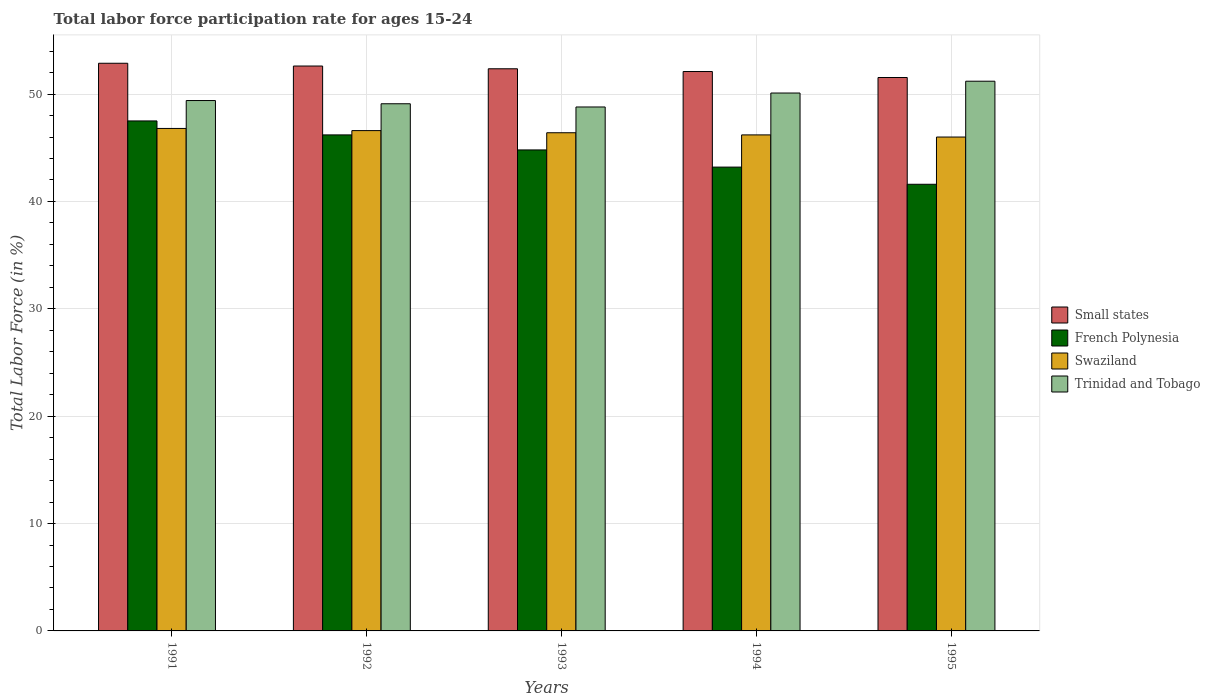Are the number of bars per tick equal to the number of legend labels?
Your answer should be compact. Yes. How many bars are there on the 4th tick from the right?
Make the answer very short. 4. What is the label of the 4th group of bars from the left?
Offer a very short reply. 1994. What is the labor force participation rate in Swaziland in 1995?
Give a very brief answer. 46. Across all years, what is the maximum labor force participation rate in Swaziland?
Provide a succinct answer. 46.8. Across all years, what is the minimum labor force participation rate in Trinidad and Tobago?
Provide a succinct answer. 48.8. What is the total labor force participation rate in Trinidad and Tobago in the graph?
Provide a short and direct response. 248.6. What is the difference between the labor force participation rate in Swaziland in 1992 and that in 1993?
Offer a terse response. 0.2. What is the difference between the labor force participation rate in French Polynesia in 1992 and the labor force participation rate in Small states in 1993?
Ensure brevity in your answer.  -6.16. What is the average labor force participation rate in Small states per year?
Your answer should be compact. 52.3. In the year 1993, what is the difference between the labor force participation rate in Swaziland and labor force participation rate in French Polynesia?
Your answer should be compact. 1.6. What is the ratio of the labor force participation rate in Small states in 1992 to that in 1993?
Offer a terse response. 1. Is the labor force participation rate in Swaziland in 1992 less than that in 1993?
Give a very brief answer. No. What is the difference between the highest and the second highest labor force participation rate in French Polynesia?
Offer a terse response. 1.3. What is the difference between the highest and the lowest labor force participation rate in Swaziland?
Ensure brevity in your answer.  0.8. Is it the case that in every year, the sum of the labor force participation rate in French Polynesia and labor force participation rate in Trinidad and Tobago is greater than the sum of labor force participation rate in Swaziland and labor force participation rate in Small states?
Offer a terse response. Yes. What does the 1st bar from the left in 1995 represents?
Ensure brevity in your answer.  Small states. What does the 1st bar from the right in 1993 represents?
Your response must be concise. Trinidad and Tobago. Does the graph contain any zero values?
Your response must be concise. No. Does the graph contain grids?
Give a very brief answer. Yes. Where does the legend appear in the graph?
Provide a short and direct response. Center right. What is the title of the graph?
Offer a terse response. Total labor force participation rate for ages 15-24. What is the label or title of the Y-axis?
Offer a very short reply. Total Labor Force (in %). What is the Total Labor Force (in %) in Small states in 1991?
Give a very brief answer. 52.87. What is the Total Labor Force (in %) in French Polynesia in 1991?
Your answer should be very brief. 47.5. What is the Total Labor Force (in %) of Swaziland in 1991?
Your response must be concise. 46.8. What is the Total Labor Force (in %) of Trinidad and Tobago in 1991?
Provide a succinct answer. 49.4. What is the Total Labor Force (in %) in Small states in 1992?
Give a very brief answer. 52.61. What is the Total Labor Force (in %) of French Polynesia in 1992?
Offer a terse response. 46.2. What is the Total Labor Force (in %) of Swaziland in 1992?
Offer a very short reply. 46.6. What is the Total Labor Force (in %) of Trinidad and Tobago in 1992?
Ensure brevity in your answer.  49.1. What is the Total Labor Force (in %) in Small states in 1993?
Give a very brief answer. 52.36. What is the Total Labor Force (in %) in French Polynesia in 1993?
Ensure brevity in your answer.  44.8. What is the Total Labor Force (in %) in Swaziland in 1993?
Your response must be concise. 46.4. What is the Total Labor Force (in %) in Trinidad and Tobago in 1993?
Provide a succinct answer. 48.8. What is the Total Labor Force (in %) of Small states in 1994?
Keep it short and to the point. 52.1. What is the Total Labor Force (in %) in French Polynesia in 1994?
Your response must be concise. 43.2. What is the Total Labor Force (in %) of Swaziland in 1994?
Give a very brief answer. 46.2. What is the Total Labor Force (in %) in Trinidad and Tobago in 1994?
Offer a very short reply. 50.1. What is the Total Labor Force (in %) in Small states in 1995?
Offer a terse response. 51.54. What is the Total Labor Force (in %) of French Polynesia in 1995?
Make the answer very short. 41.6. What is the Total Labor Force (in %) of Trinidad and Tobago in 1995?
Give a very brief answer. 51.2. Across all years, what is the maximum Total Labor Force (in %) of Small states?
Give a very brief answer. 52.87. Across all years, what is the maximum Total Labor Force (in %) of French Polynesia?
Your answer should be compact. 47.5. Across all years, what is the maximum Total Labor Force (in %) of Swaziland?
Provide a succinct answer. 46.8. Across all years, what is the maximum Total Labor Force (in %) of Trinidad and Tobago?
Provide a short and direct response. 51.2. Across all years, what is the minimum Total Labor Force (in %) in Small states?
Offer a terse response. 51.54. Across all years, what is the minimum Total Labor Force (in %) of French Polynesia?
Your answer should be very brief. 41.6. Across all years, what is the minimum Total Labor Force (in %) in Trinidad and Tobago?
Provide a short and direct response. 48.8. What is the total Total Labor Force (in %) of Small states in the graph?
Offer a terse response. 261.49. What is the total Total Labor Force (in %) of French Polynesia in the graph?
Your answer should be very brief. 223.3. What is the total Total Labor Force (in %) of Swaziland in the graph?
Keep it short and to the point. 232. What is the total Total Labor Force (in %) of Trinidad and Tobago in the graph?
Give a very brief answer. 248.6. What is the difference between the Total Labor Force (in %) in Small states in 1991 and that in 1992?
Provide a short and direct response. 0.26. What is the difference between the Total Labor Force (in %) in Small states in 1991 and that in 1993?
Make the answer very short. 0.51. What is the difference between the Total Labor Force (in %) of French Polynesia in 1991 and that in 1993?
Make the answer very short. 2.7. What is the difference between the Total Labor Force (in %) of Swaziland in 1991 and that in 1993?
Provide a short and direct response. 0.4. What is the difference between the Total Labor Force (in %) of Small states in 1991 and that in 1994?
Keep it short and to the point. 0.77. What is the difference between the Total Labor Force (in %) of Small states in 1991 and that in 1995?
Offer a terse response. 1.33. What is the difference between the Total Labor Force (in %) in Swaziland in 1991 and that in 1995?
Your answer should be compact. 0.8. What is the difference between the Total Labor Force (in %) in Small states in 1992 and that in 1993?
Provide a short and direct response. 0.26. What is the difference between the Total Labor Force (in %) in Small states in 1992 and that in 1994?
Ensure brevity in your answer.  0.51. What is the difference between the Total Labor Force (in %) in French Polynesia in 1992 and that in 1994?
Provide a succinct answer. 3. What is the difference between the Total Labor Force (in %) of Swaziland in 1992 and that in 1994?
Ensure brevity in your answer.  0.4. What is the difference between the Total Labor Force (in %) in Small states in 1992 and that in 1995?
Keep it short and to the point. 1.07. What is the difference between the Total Labor Force (in %) in French Polynesia in 1992 and that in 1995?
Keep it short and to the point. 4.6. What is the difference between the Total Labor Force (in %) of Swaziland in 1992 and that in 1995?
Your response must be concise. 0.6. What is the difference between the Total Labor Force (in %) in Trinidad and Tobago in 1992 and that in 1995?
Keep it short and to the point. -2.1. What is the difference between the Total Labor Force (in %) in Small states in 1993 and that in 1994?
Make the answer very short. 0.25. What is the difference between the Total Labor Force (in %) of Swaziland in 1993 and that in 1994?
Provide a short and direct response. 0.2. What is the difference between the Total Labor Force (in %) of Small states in 1993 and that in 1995?
Provide a short and direct response. 0.81. What is the difference between the Total Labor Force (in %) of Trinidad and Tobago in 1993 and that in 1995?
Your response must be concise. -2.4. What is the difference between the Total Labor Force (in %) of Small states in 1994 and that in 1995?
Offer a very short reply. 0.56. What is the difference between the Total Labor Force (in %) in Trinidad and Tobago in 1994 and that in 1995?
Ensure brevity in your answer.  -1.1. What is the difference between the Total Labor Force (in %) in Small states in 1991 and the Total Labor Force (in %) in French Polynesia in 1992?
Offer a very short reply. 6.67. What is the difference between the Total Labor Force (in %) of Small states in 1991 and the Total Labor Force (in %) of Swaziland in 1992?
Make the answer very short. 6.27. What is the difference between the Total Labor Force (in %) in Small states in 1991 and the Total Labor Force (in %) in Trinidad and Tobago in 1992?
Offer a very short reply. 3.77. What is the difference between the Total Labor Force (in %) of French Polynesia in 1991 and the Total Labor Force (in %) of Trinidad and Tobago in 1992?
Provide a succinct answer. -1.6. What is the difference between the Total Labor Force (in %) of Small states in 1991 and the Total Labor Force (in %) of French Polynesia in 1993?
Offer a terse response. 8.07. What is the difference between the Total Labor Force (in %) of Small states in 1991 and the Total Labor Force (in %) of Swaziland in 1993?
Offer a terse response. 6.47. What is the difference between the Total Labor Force (in %) in Small states in 1991 and the Total Labor Force (in %) in Trinidad and Tobago in 1993?
Your answer should be compact. 4.07. What is the difference between the Total Labor Force (in %) of Small states in 1991 and the Total Labor Force (in %) of French Polynesia in 1994?
Offer a very short reply. 9.67. What is the difference between the Total Labor Force (in %) in Small states in 1991 and the Total Labor Force (in %) in Swaziland in 1994?
Offer a very short reply. 6.67. What is the difference between the Total Labor Force (in %) of Small states in 1991 and the Total Labor Force (in %) of Trinidad and Tobago in 1994?
Your answer should be compact. 2.77. What is the difference between the Total Labor Force (in %) in French Polynesia in 1991 and the Total Labor Force (in %) in Trinidad and Tobago in 1994?
Your response must be concise. -2.6. What is the difference between the Total Labor Force (in %) in Small states in 1991 and the Total Labor Force (in %) in French Polynesia in 1995?
Provide a short and direct response. 11.27. What is the difference between the Total Labor Force (in %) in Small states in 1991 and the Total Labor Force (in %) in Swaziland in 1995?
Offer a terse response. 6.87. What is the difference between the Total Labor Force (in %) of Small states in 1991 and the Total Labor Force (in %) of Trinidad and Tobago in 1995?
Your answer should be very brief. 1.67. What is the difference between the Total Labor Force (in %) of French Polynesia in 1991 and the Total Labor Force (in %) of Swaziland in 1995?
Offer a very short reply. 1.5. What is the difference between the Total Labor Force (in %) of French Polynesia in 1991 and the Total Labor Force (in %) of Trinidad and Tobago in 1995?
Your response must be concise. -3.7. What is the difference between the Total Labor Force (in %) in Small states in 1992 and the Total Labor Force (in %) in French Polynesia in 1993?
Your response must be concise. 7.81. What is the difference between the Total Labor Force (in %) in Small states in 1992 and the Total Labor Force (in %) in Swaziland in 1993?
Offer a very short reply. 6.21. What is the difference between the Total Labor Force (in %) of Small states in 1992 and the Total Labor Force (in %) of Trinidad and Tobago in 1993?
Provide a short and direct response. 3.81. What is the difference between the Total Labor Force (in %) in French Polynesia in 1992 and the Total Labor Force (in %) in Trinidad and Tobago in 1993?
Offer a terse response. -2.6. What is the difference between the Total Labor Force (in %) of Small states in 1992 and the Total Labor Force (in %) of French Polynesia in 1994?
Keep it short and to the point. 9.41. What is the difference between the Total Labor Force (in %) in Small states in 1992 and the Total Labor Force (in %) in Swaziland in 1994?
Your response must be concise. 6.41. What is the difference between the Total Labor Force (in %) in Small states in 1992 and the Total Labor Force (in %) in Trinidad and Tobago in 1994?
Offer a very short reply. 2.51. What is the difference between the Total Labor Force (in %) of French Polynesia in 1992 and the Total Labor Force (in %) of Trinidad and Tobago in 1994?
Make the answer very short. -3.9. What is the difference between the Total Labor Force (in %) of Swaziland in 1992 and the Total Labor Force (in %) of Trinidad and Tobago in 1994?
Your response must be concise. -3.5. What is the difference between the Total Labor Force (in %) in Small states in 1992 and the Total Labor Force (in %) in French Polynesia in 1995?
Give a very brief answer. 11.01. What is the difference between the Total Labor Force (in %) in Small states in 1992 and the Total Labor Force (in %) in Swaziland in 1995?
Offer a terse response. 6.61. What is the difference between the Total Labor Force (in %) of Small states in 1992 and the Total Labor Force (in %) of Trinidad and Tobago in 1995?
Ensure brevity in your answer.  1.41. What is the difference between the Total Labor Force (in %) in French Polynesia in 1992 and the Total Labor Force (in %) in Trinidad and Tobago in 1995?
Give a very brief answer. -5. What is the difference between the Total Labor Force (in %) of Swaziland in 1992 and the Total Labor Force (in %) of Trinidad and Tobago in 1995?
Offer a very short reply. -4.6. What is the difference between the Total Labor Force (in %) in Small states in 1993 and the Total Labor Force (in %) in French Polynesia in 1994?
Your response must be concise. 9.16. What is the difference between the Total Labor Force (in %) in Small states in 1993 and the Total Labor Force (in %) in Swaziland in 1994?
Make the answer very short. 6.16. What is the difference between the Total Labor Force (in %) of Small states in 1993 and the Total Labor Force (in %) of Trinidad and Tobago in 1994?
Provide a short and direct response. 2.26. What is the difference between the Total Labor Force (in %) in French Polynesia in 1993 and the Total Labor Force (in %) in Swaziland in 1994?
Ensure brevity in your answer.  -1.4. What is the difference between the Total Labor Force (in %) of French Polynesia in 1993 and the Total Labor Force (in %) of Trinidad and Tobago in 1994?
Provide a succinct answer. -5.3. What is the difference between the Total Labor Force (in %) in Swaziland in 1993 and the Total Labor Force (in %) in Trinidad and Tobago in 1994?
Make the answer very short. -3.7. What is the difference between the Total Labor Force (in %) in Small states in 1993 and the Total Labor Force (in %) in French Polynesia in 1995?
Your answer should be very brief. 10.76. What is the difference between the Total Labor Force (in %) of Small states in 1993 and the Total Labor Force (in %) of Swaziland in 1995?
Offer a very short reply. 6.36. What is the difference between the Total Labor Force (in %) of Small states in 1993 and the Total Labor Force (in %) of Trinidad and Tobago in 1995?
Provide a short and direct response. 1.16. What is the difference between the Total Labor Force (in %) of French Polynesia in 1993 and the Total Labor Force (in %) of Trinidad and Tobago in 1995?
Your answer should be compact. -6.4. What is the difference between the Total Labor Force (in %) in Small states in 1994 and the Total Labor Force (in %) in French Polynesia in 1995?
Your answer should be very brief. 10.5. What is the difference between the Total Labor Force (in %) in Small states in 1994 and the Total Labor Force (in %) in Swaziland in 1995?
Make the answer very short. 6.1. What is the difference between the Total Labor Force (in %) in Small states in 1994 and the Total Labor Force (in %) in Trinidad and Tobago in 1995?
Ensure brevity in your answer.  0.9. What is the difference between the Total Labor Force (in %) in French Polynesia in 1994 and the Total Labor Force (in %) in Swaziland in 1995?
Provide a short and direct response. -2.8. What is the average Total Labor Force (in %) of Small states per year?
Your response must be concise. 52.3. What is the average Total Labor Force (in %) in French Polynesia per year?
Offer a terse response. 44.66. What is the average Total Labor Force (in %) of Swaziland per year?
Your response must be concise. 46.4. What is the average Total Labor Force (in %) of Trinidad and Tobago per year?
Offer a very short reply. 49.72. In the year 1991, what is the difference between the Total Labor Force (in %) in Small states and Total Labor Force (in %) in French Polynesia?
Give a very brief answer. 5.37. In the year 1991, what is the difference between the Total Labor Force (in %) of Small states and Total Labor Force (in %) of Swaziland?
Ensure brevity in your answer.  6.07. In the year 1991, what is the difference between the Total Labor Force (in %) in Small states and Total Labor Force (in %) in Trinidad and Tobago?
Make the answer very short. 3.47. In the year 1991, what is the difference between the Total Labor Force (in %) in French Polynesia and Total Labor Force (in %) in Swaziland?
Your answer should be compact. 0.7. In the year 1992, what is the difference between the Total Labor Force (in %) of Small states and Total Labor Force (in %) of French Polynesia?
Offer a very short reply. 6.41. In the year 1992, what is the difference between the Total Labor Force (in %) in Small states and Total Labor Force (in %) in Swaziland?
Make the answer very short. 6.01. In the year 1992, what is the difference between the Total Labor Force (in %) of Small states and Total Labor Force (in %) of Trinidad and Tobago?
Your answer should be very brief. 3.51. In the year 1992, what is the difference between the Total Labor Force (in %) of Swaziland and Total Labor Force (in %) of Trinidad and Tobago?
Ensure brevity in your answer.  -2.5. In the year 1993, what is the difference between the Total Labor Force (in %) in Small states and Total Labor Force (in %) in French Polynesia?
Keep it short and to the point. 7.56. In the year 1993, what is the difference between the Total Labor Force (in %) of Small states and Total Labor Force (in %) of Swaziland?
Your answer should be compact. 5.96. In the year 1993, what is the difference between the Total Labor Force (in %) of Small states and Total Labor Force (in %) of Trinidad and Tobago?
Give a very brief answer. 3.56. In the year 1994, what is the difference between the Total Labor Force (in %) of Small states and Total Labor Force (in %) of French Polynesia?
Make the answer very short. 8.9. In the year 1994, what is the difference between the Total Labor Force (in %) of Small states and Total Labor Force (in %) of Swaziland?
Offer a terse response. 5.9. In the year 1994, what is the difference between the Total Labor Force (in %) of Small states and Total Labor Force (in %) of Trinidad and Tobago?
Offer a very short reply. 2. In the year 1994, what is the difference between the Total Labor Force (in %) in French Polynesia and Total Labor Force (in %) in Swaziland?
Your response must be concise. -3. In the year 1995, what is the difference between the Total Labor Force (in %) in Small states and Total Labor Force (in %) in French Polynesia?
Make the answer very short. 9.94. In the year 1995, what is the difference between the Total Labor Force (in %) in Small states and Total Labor Force (in %) in Swaziland?
Ensure brevity in your answer.  5.54. In the year 1995, what is the difference between the Total Labor Force (in %) of Small states and Total Labor Force (in %) of Trinidad and Tobago?
Give a very brief answer. 0.34. In the year 1995, what is the difference between the Total Labor Force (in %) of Swaziland and Total Labor Force (in %) of Trinidad and Tobago?
Provide a succinct answer. -5.2. What is the ratio of the Total Labor Force (in %) of French Polynesia in 1991 to that in 1992?
Ensure brevity in your answer.  1.03. What is the ratio of the Total Labor Force (in %) in Swaziland in 1991 to that in 1992?
Make the answer very short. 1. What is the ratio of the Total Labor Force (in %) of Trinidad and Tobago in 1991 to that in 1992?
Keep it short and to the point. 1.01. What is the ratio of the Total Labor Force (in %) of Small states in 1991 to that in 1993?
Your answer should be very brief. 1.01. What is the ratio of the Total Labor Force (in %) of French Polynesia in 1991 to that in 1993?
Offer a terse response. 1.06. What is the ratio of the Total Labor Force (in %) in Swaziland in 1991 to that in 1993?
Keep it short and to the point. 1.01. What is the ratio of the Total Labor Force (in %) of Trinidad and Tobago in 1991 to that in 1993?
Your answer should be compact. 1.01. What is the ratio of the Total Labor Force (in %) of Small states in 1991 to that in 1994?
Make the answer very short. 1.01. What is the ratio of the Total Labor Force (in %) of French Polynesia in 1991 to that in 1994?
Ensure brevity in your answer.  1.1. What is the ratio of the Total Labor Force (in %) in Trinidad and Tobago in 1991 to that in 1994?
Offer a very short reply. 0.99. What is the ratio of the Total Labor Force (in %) of Small states in 1991 to that in 1995?
Keep it short and to the point. 1.03. What is the ratio of the Total Labor Force (in %) in French Polynesia in 1991 to that in 1995?
Ensure brevity in your answer.  1.14. What is the ratio of the Total Labor Force (in %) of Swaziland in 1991 to that in 1995?
Provide a succinct answer. 1.02. What is the ratio of the Total Labor Force (in %) of Trinidad and Tobago in 1991 to that in 1995?
Your answer should be very brief. 0.96. What is the ratio of the Total Labor Force (in %) of Small states in 1992 to that in 1993?
Your response must be concise. 1. What is the ratio of the Total Labor Force (in %) in French Polynesia in 1992 to that in 1993?
Give a very brief answer. 1.03. What is the ratio of the Total Labor Force (in %) in Swaziland in 1992 to that in 1993?
Provide a succinct answer. 1. What is the ratio of the Total Labor Force (in %) of Trinidad and Tobago in 1992 to that in 1993?
Keep it short and to the point. 1.01. What is the ratio of the Total Labor Force (in %) in Small states in 1992 to that in 1994?
Provide a succinct answer. 1.01. What is the ratio of the Total Labor Force (in %) in French Polynesia in 1992 to that in 1994?
Make the answer very short. 1.07. What is the ratio of the Total Labor Force (in %) in Swaziland in 1992 to that in 1994?
Your response must be concise. 1.01. What is the ratio of the Total Labor Force (in %) in Small states in 1992 to that in 1995?
Offer a very short reply. 1.02. What is the ratio of the Total Labor Force (in %) of French Polynesia in 1992 to that in 1995?
Your answer should be very brief. 1.11. What is the ratio of the Total Labor Force (in %) of Swaziland in 1992 to that in 1995?
Your response must be concise. 1.01. What is the ratio of the Total Labor Force (in %) in Trinidad and Tobago in 1993 to that in 1994?
Ensure brevity in your answer.  0.97. What is the ratio of the Total Labor Force (in %) of Small states in 1993 to that in 1995?
Offer a terse response. 1.02. What is the ratio of the Total Labor Force (in %) of Swaziland in 1993 to that in 1995?
Your response must be concise. 1.01. What is the ratio of the Total Labor Force (in %) of Trinidad and Tobago in 1993 to that in 1995?
Give a very brief answer. 0.95. What is the ratio of the Total Labor Force (in %) in Small states in 1994 to that in 1995?
Your response must be concise. 1.01. What is the ratio of the Total Labor Force (in %) of Trinidad and Tobago in 1994 to that in 1995?
Give a very brief answer. 0.98. What is the difference between the highest and the second highest Total Labor Force (in %) of Small states?
Provide a succinct answer. 0.26. What is the difference between the highest and the lowest Total Labor Force (in %) in Small states?
Offer a terse response. 1.33. What is the difference between the highest and the lowest Total Labor Force (in %) of French Polynesia?
Your answer should be compact. 5.9. What is the difference between the highest and the lowest Total Labor Force (in %) in Trinidad and Tobago?
Keep it short and to the point. 2.4. 